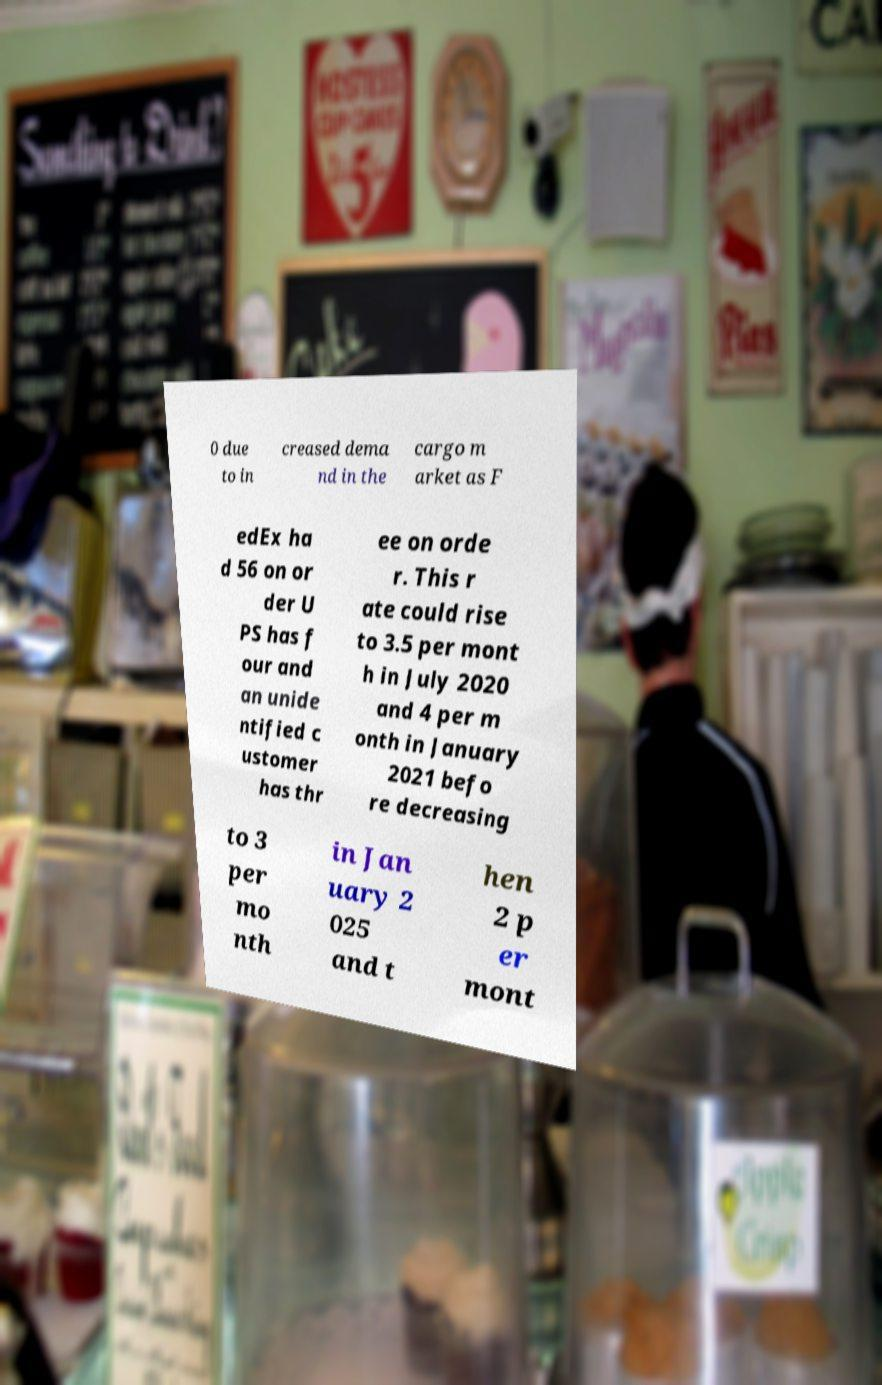For documentation purposes, I need the text within this image transcribed. Could you provide that? 0 due to in creased dema nd in the cargo m arket as F edEx ha d 56 on or der U PS has f our and an unide ntified c ustomer has thr ee on orde r. This r ate could rise to 3.5 per mont h in July 2020 and 4 per m onth in January 2021 befo re decreasing to 3 per mo nth in Jan uary 2 025 and t hen 2 p er mont 